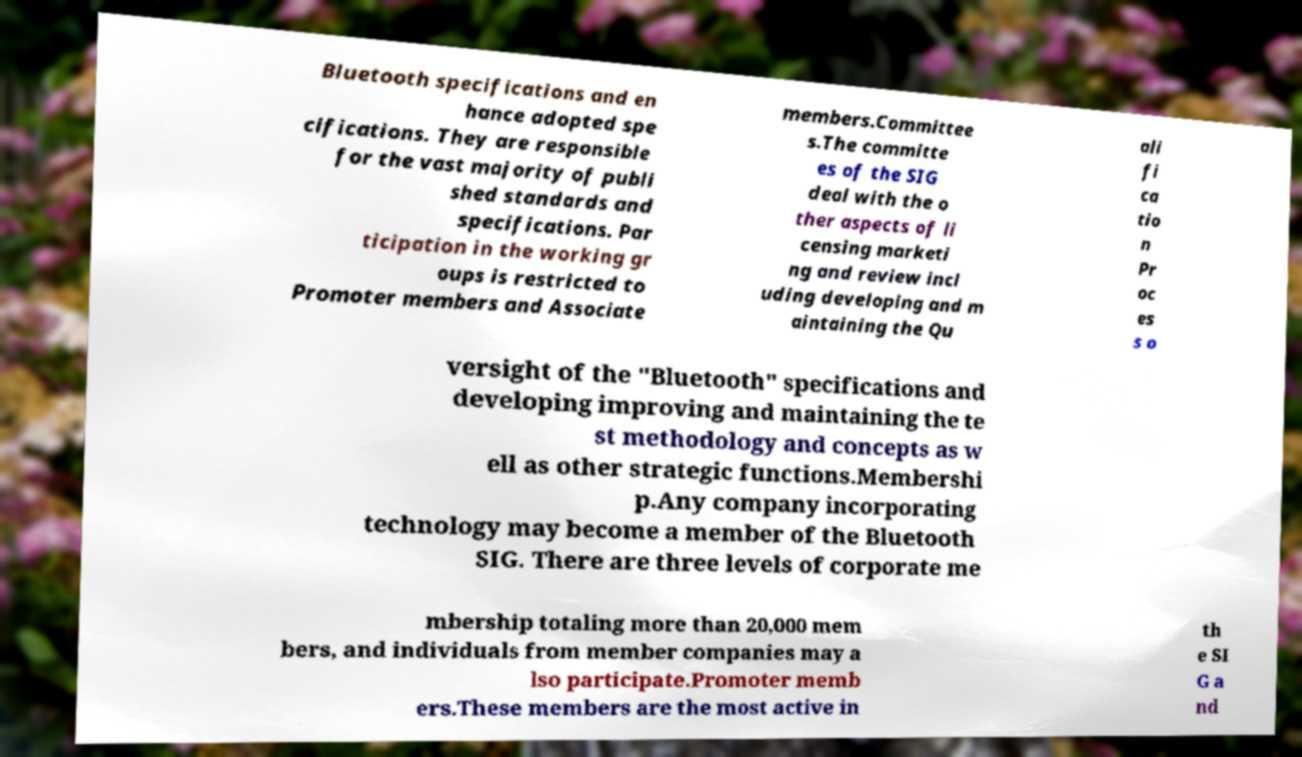Please read and relay the text visible in this image. What does it say? Bluetooth specifications and en hance adopted spe cifications. They are responsible for the vast majority of publi shed standards and specifications. Par ticipation in the working gr oups is restricted to Promoter members and Associate members.Committee s.The committe es of the SIG deal with the o ther aspects of li censing marketi ng and review incl uding developing and m aintaining the Qu ali fi ca tio n Pr oc es s o versight of the "Bluetooth" specifications and developing improving and maintaining the te st methodology and concepts as w ell as other strategic functions.Membershi p.Any company incorporating technology may become a member of the Bluetooth SIG. There are three levels of corporate me mbership totaling more than 20,000 mem bers, and individuals from member companies may a lso participate.Promoter memb ers.These members are the most active in th e SI G a nd 